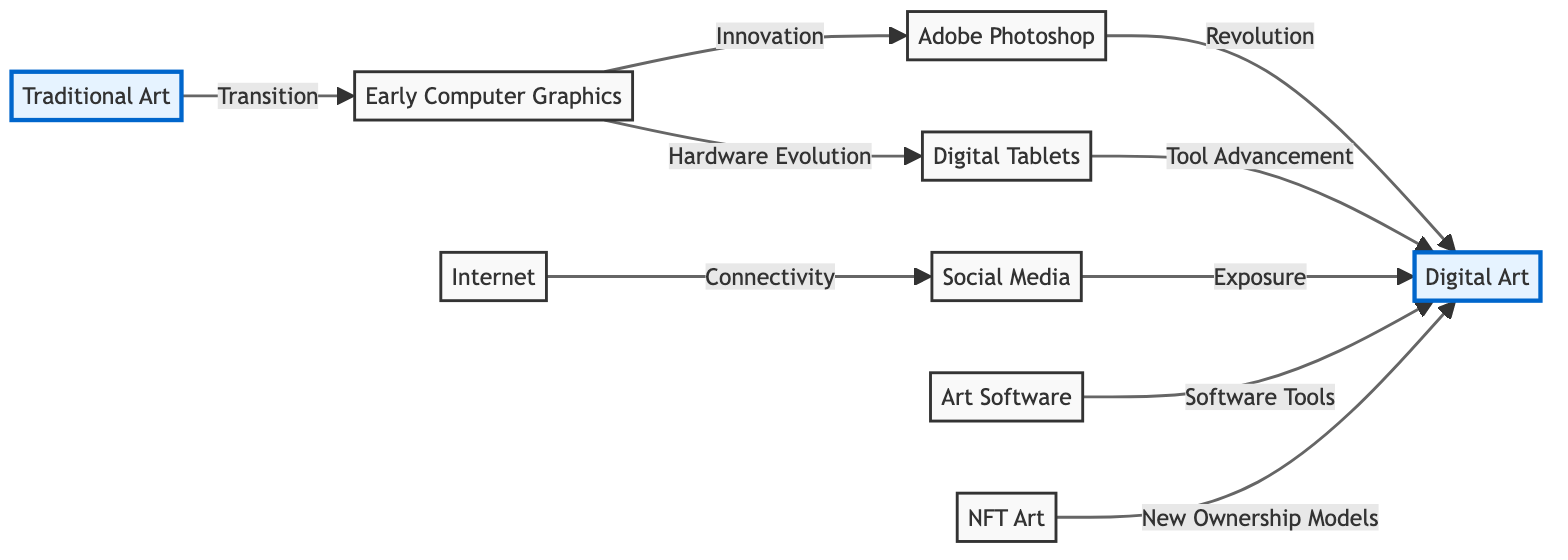What is the first node in the diagram? The first node listed is "Traditional Art", indicating the starting point of the transition towards digital art.
Answer: Traditional Art How many edges are present in the diagram? The diagram shows a total of 8 directed edges connecting various nodes, representing the relationships and transitions between different types of art and technology.
Answer: 8 What does the edge between "Adobe Photoshop" and "Digital Art" represent? The edge labeled with "Revolution" indicates that Adobe Photoshop significantly transformed the practice and perception of Digital Art.
Answer: Revolution Which node is directly connected to "Internet" in the diagram? The node "Social Media" is linked directly to "Internet", signifying the role of the Internet in facilitating social media platforms for artists.
Answer: Social Media What type of technology does "Digital Tablets" represent? "Digital Tablets" refer to hardware technology that emerged in the 1990s, providing new tools specifically for digital artists.
Answer: Hardware What connection does "NFT Art" have in relation to "Digital Art"? The connection indicates that NFT Art introduces "New Ownership Models" to the domain of Digital Art, reflecting the evolving landscape of art ownership.
Answer: New Ownership Models How does "Social Media" influence "Digital Art"? The label "Exposure" signifies that social media platforms provide enhanced visibility and sharing opportunities for digital artists, influencing their reach.
Answer: Exposure What was the primary transition depicted from "Traditional Art" to "Early Computer Graphics"? The edge labeled "Transition" signifies the movement from traditional methods to the initial stages of computer graphics in art creation.
Answer: Transition What label describes the relationship between "Early Computer Graphics" and "Digital Tablets"? The label "Hardware Evolution" describes how advancements in hardware technology facilitated the progression from early graphics to more sophisticated digital creation tools.
Answer: Hardware Evolution 